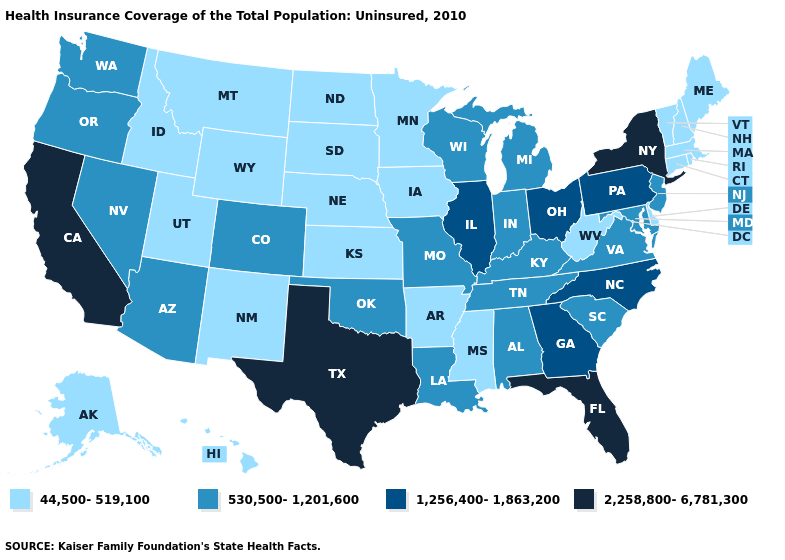Name the states that have a value in the range 44,500-519,100?
Keep it brief. Alaska, Arkansas, Connecticut, Delaware, Hawaii, Idaho, Iowa, Kansas, Maine, Massachusetts, Minnesota, Mississippi, Montana, Nebraska, New Hampshire, New Mexico, North Dakota, Rhode Island, South Dakota, Utah, Vermont, West Virginia, Wyoming. Name the states that have a value in the range 2,258,800-6,781,300?
Write a very short answer. California, Florida, New York, Texas. Among the states that border Missouri , which have the highest value?
Concise answer only. Illinois. Which states have the lowest value in the USA?
Short answer required. Alaska, Arkansas, Connecticut, Delaware, Hawaii, Idaho, Iowa, Kansas, Maine, Massachusetts, Minnesota, Mississippi, Montana, Nebraska, New Hampshire, New Mexico, North Dakota, Rhode Island, South Dakota, Utah, Vermont, West Virginia, Wyoming. Name the states that have a value in the range 1,256,400-1,863,200?
Be succinct. Georgia, Illinois, North Carolina, Ohio, Pennsylvania. Name the states that have a value in the range 2,258,800-6,781,300?
Write a very short answer. California, Florida, New York, Texas. What is the value of Colorado?
Keep it brief. 530,500-1,201,600. What is the value of Oregon?
Concise answer only. 530,500-1,201,600. Name the states that have a value in the range 2,258,800-6,781,300?
Answer briefly. California, Florida, New York, Texas. Among the states that border New Mexico , which have the highest value?
Quick response, please. Texas. Which states have the lowest value in the South?
Short answer required. Arkansas, Delaware, Mississippi, West Virginia. Name the states that have a value in the range 44,500-519,100?
Short answer required. Alaska, Arkansas, Connecticut, Delaware, Hawaii, Idaho, Iowa, Kansas, Maine, Massachusetts, Minnesota, Mississippi, Montana, Nebraska, New Hampshire, New Mexico, North Dakota, Rhode Island, South Dakota, Utah, Vermont, West Virginia, Wyoming. Among the states that border Virginia , does Kentucky have the highest value?
Give a very brief answer. No. What is the lowest value in the MidWest?
Give a very brief answer. 44,500-519,100. What is the value of Maryland?
Be succinct. 530,500-1,201,600. 